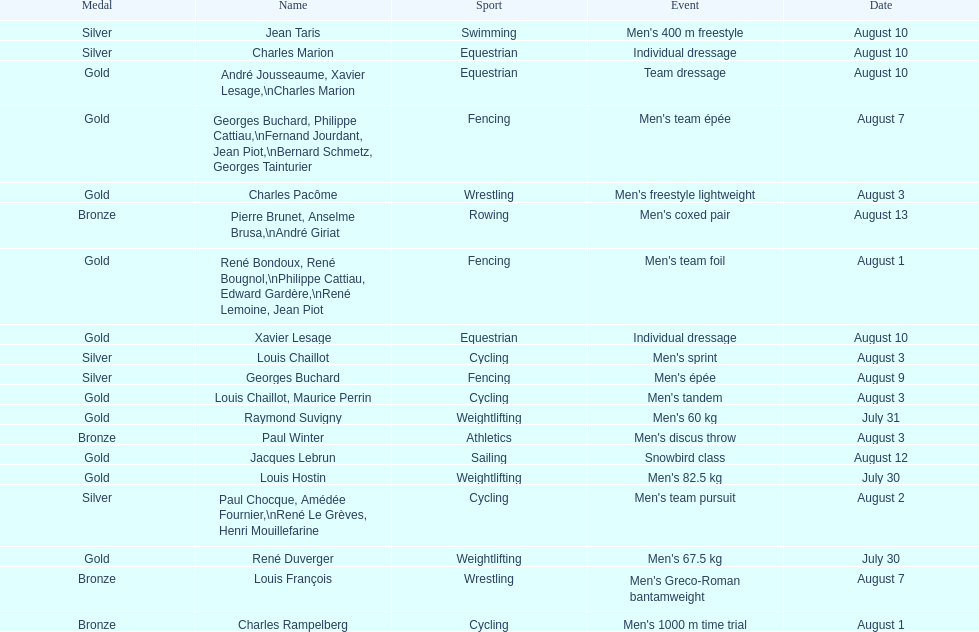What is next date that is listed after august 7th? August 1. 